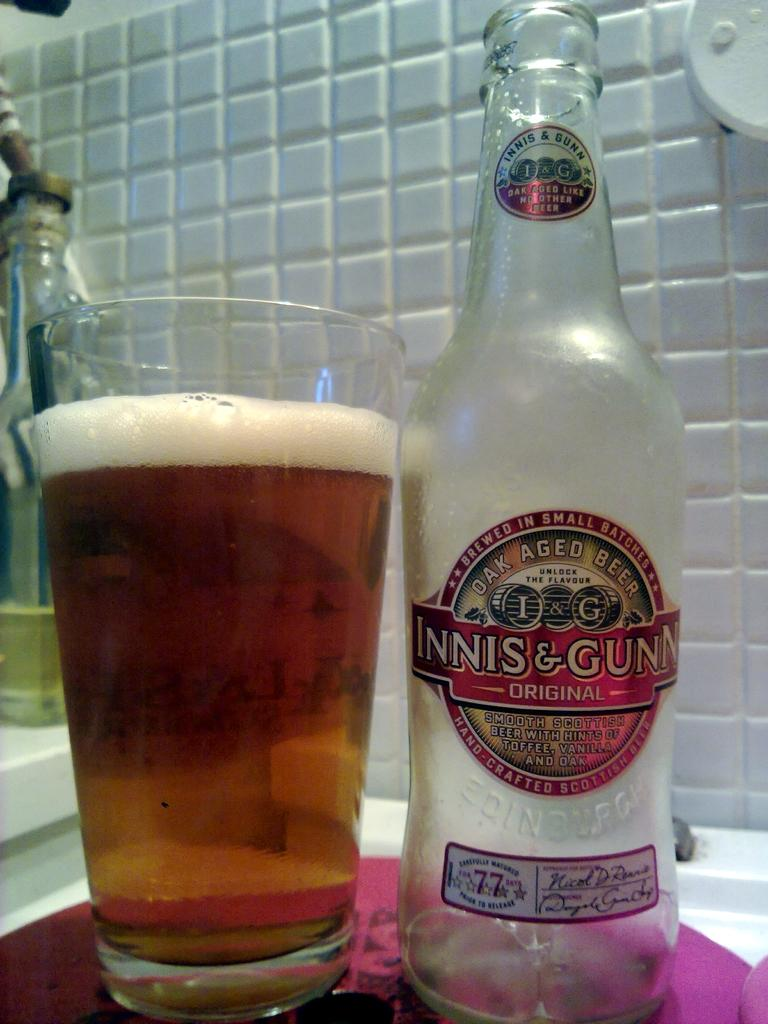<image>
Summarize the visual content of the image. An empty bottle of Innis and Gunn by a glass full of beer. 